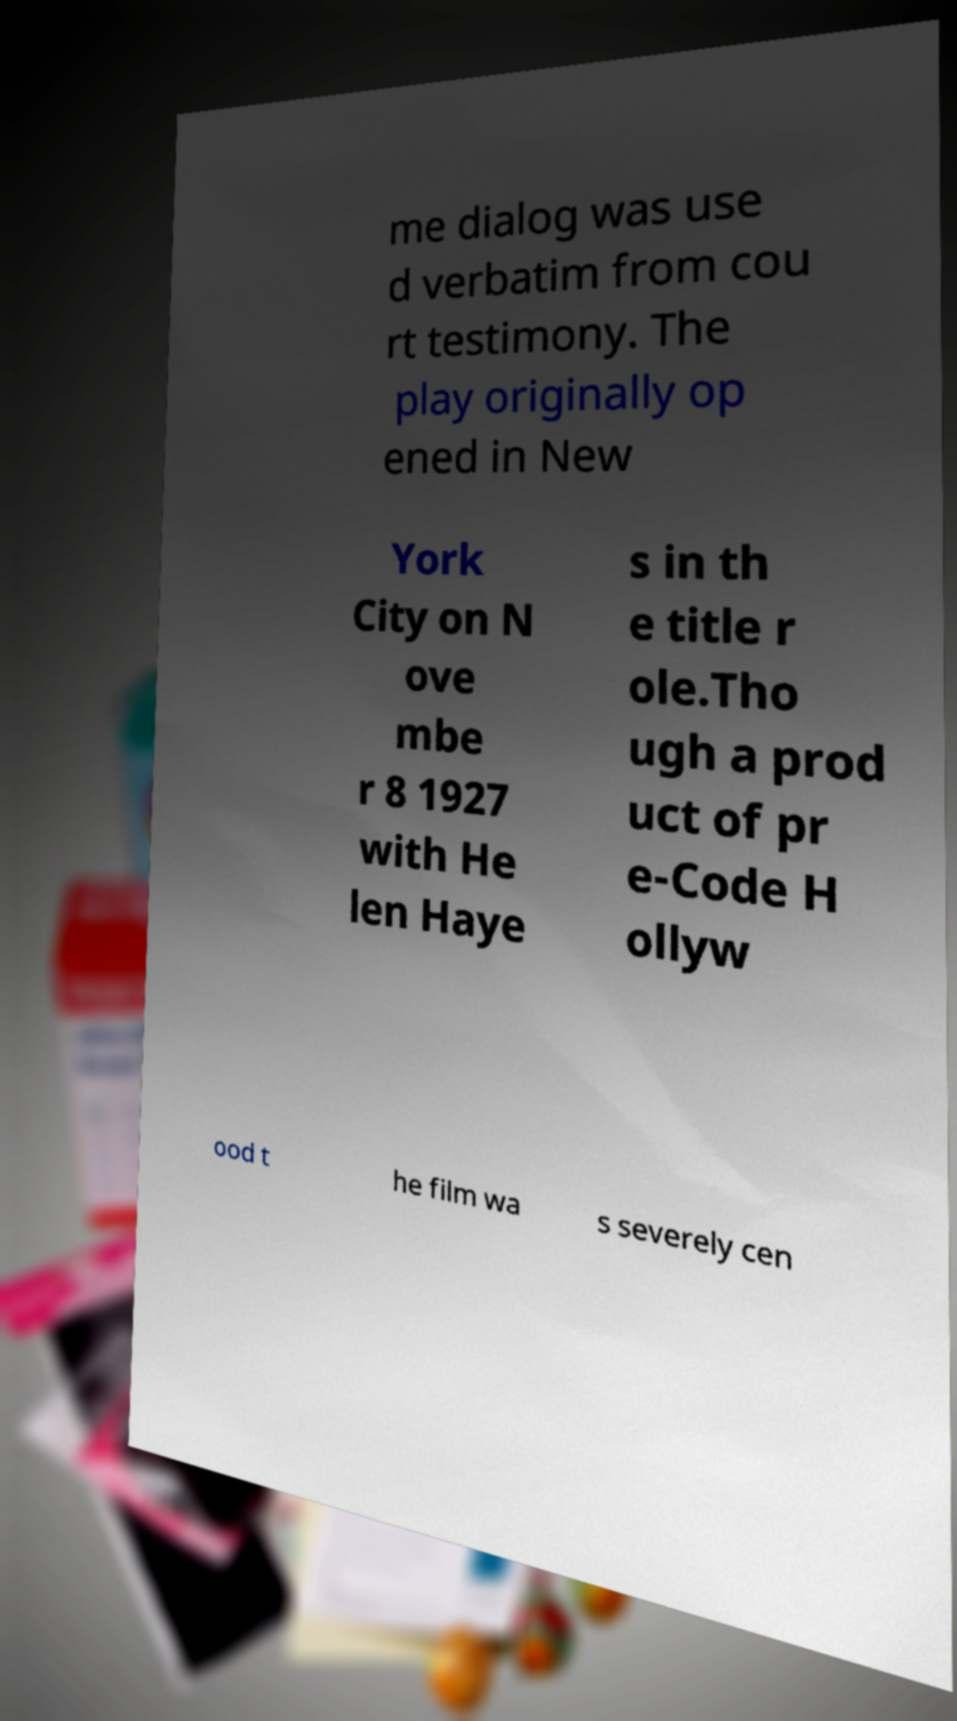What messages or text are displayed in this image? I need them in a readable, typed format. me dialog was use d verbatim from cou rt testimony. The play originally op ened in New York City on N ove mbe r 8 1927 with He len Haye s in th e title r ole.Tho ugh a prod uct of pr e-Code H ollyw ood t he film wa s severely cen 